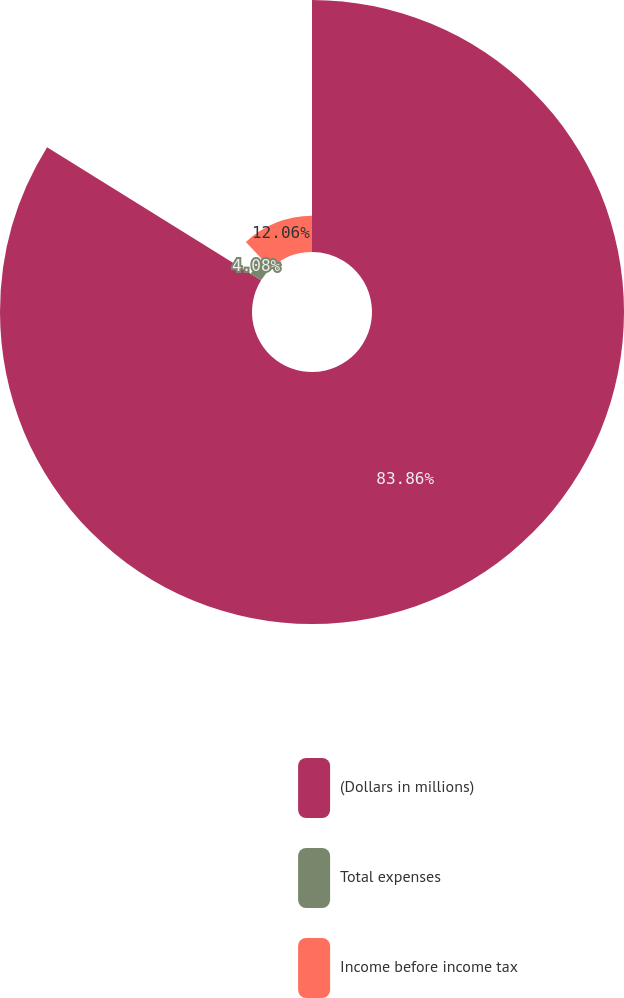Convert chart to OTSL. <chart><loc_0><loc_0><loc_500><loc_500><pie_chart><fcel>(Dollars in millions)<fcel>Total expenses<fcel>Income before income tax<nl><fcel>83.86%<fcel>4.08%<fcel>12.06%<nl></chart> 